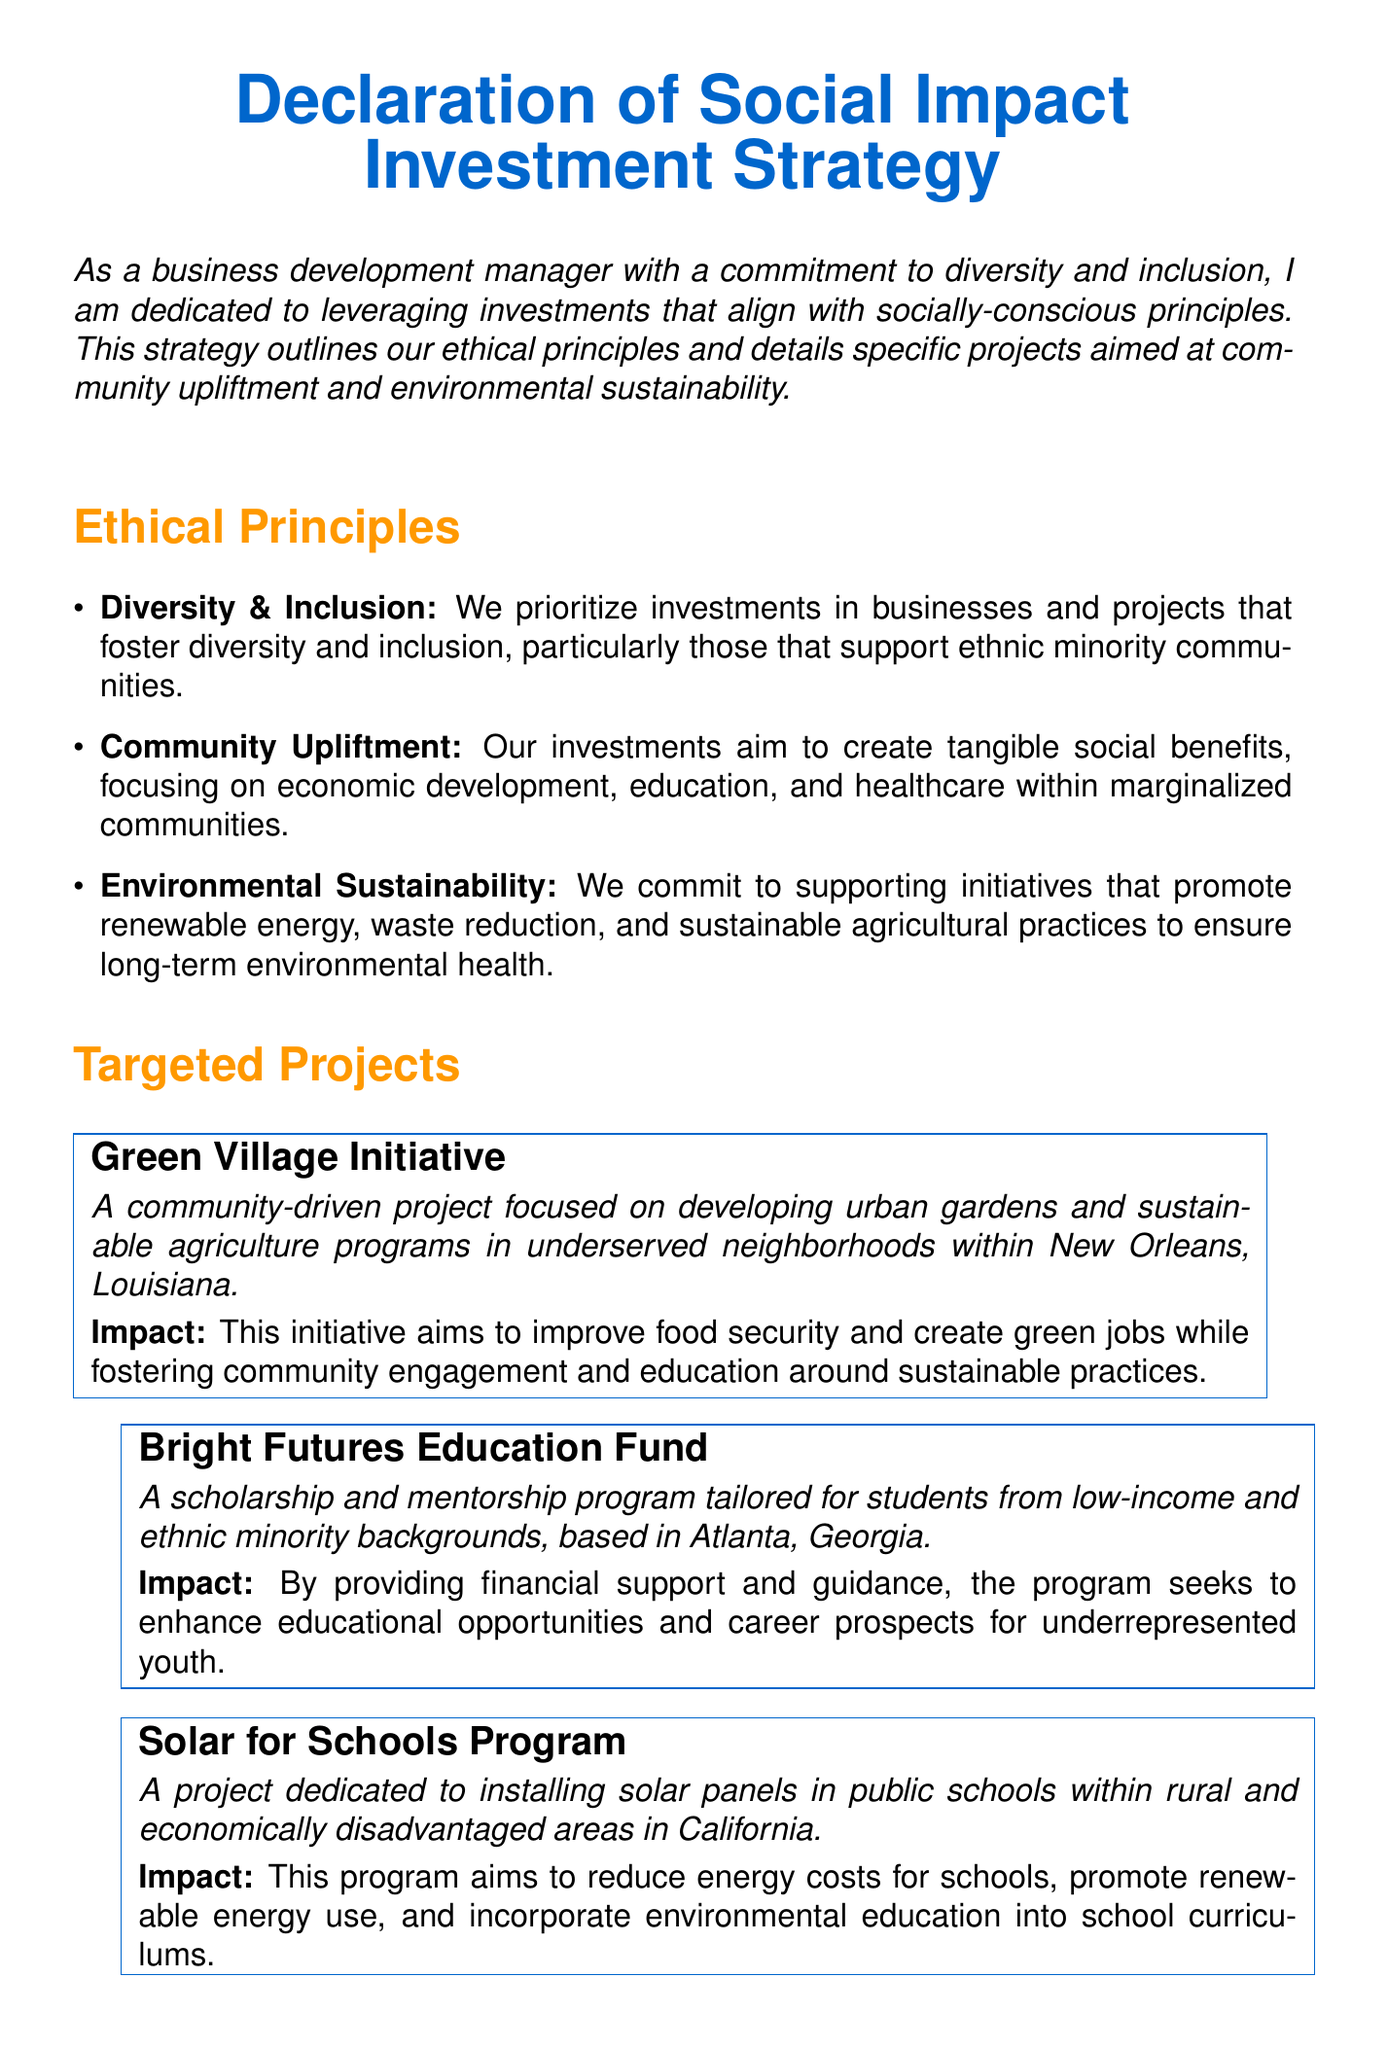What is the title of the document? The title of the document is prominently displayed at the top and indicates the focus of the content.
Answer: Declaration of Social Impact Investment Strategy What year is the date signed? The date signed is represented by the placeholder and updates automatically to the current date.
Answer: Today's date Which project focuses on education in Atlanta? The project that is mentioned in relation to education specifically targets students in Atlanta and describes its purpose.
Answer: Bright Futures Education Fund What is one ethical principle mentioned? The document clearly lists several ethical principles that guide the investment strategy.
Answer: Diversity & Inclusion What city is the Green Village Initiative located in? This project is specifically identified in the document, including its location in the description.
Answer: New Orleans What is the main aim of the Solar for Schools Program? The document outlines the objectives of this project, which are shared in the description box.
Answer: Reduce energy costs How many targeted projects are listed in the document? The number of projects mentioned can be counted directly from the targeted projects section.
Answer: Three What type of community upliftment does the Green Village Initiative promote? This initiative focuses on a specific aspect of community benefit as described in its impact statement.
Answer: Food security What color is used for the title of the document? The title is presented in a specific color that enhances its visibility as highlighted in the formatting details.
Answer: Main color 